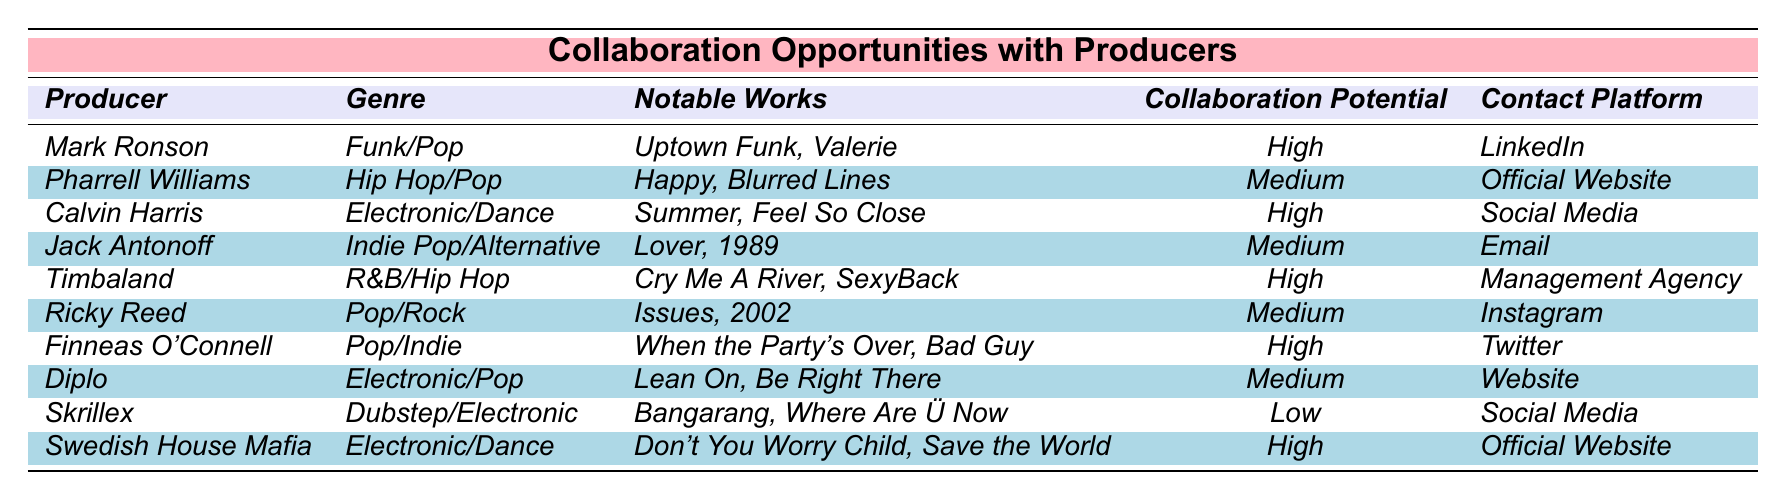What are the contact platforms for Calvin Harris and Timbaland? According to the table, Calvin Harris is reachable via Social Media while Timbaland can be contacted through a Management Agency.
Answer: Social Media and Management Agency Who are the producers listed with a high collaboration potential? The table indicates that Mark Ronson, Calvin Harris, Timbaland, Finneas O'Connell, and Swedish House Mafia all have a collaboration potential rated as high.
Answer: Mark Ronson, Calvin Harris, Timbaland, Finneas O'Connell, Swedish House Mafia Is Timabaland associated with Pop genre? The table shows that Timbaland is categorized under R&B/Hip Hop, not Pop.
Answer: No How many producers are listed as having medium collaboration potential? By counting the entries with medium collaboration potential in the table, we see there are four producers: Pharrell Williams, Jack Antonoff, Ricky Reed, and Diplo.
Answer: 4 Which producer has the most notable works mentioned? By assessing the notable works for each producer, "Uptown Funk, Valerie" by Mark Ronson and "Happy, Blurred Lines" by Pharrell Williams both seem notable, but it is subjective; however, the answer depends on personal familiarity.
Answer: Subjective (depends on the listener) What genre of music does Finnish O'Connell produce? The table categorizes Finneas O'Connell under Pop/Indie genre.
Answer: Pop/Indie Are there any producers from the Electronic/Dance genre with a high collaboration potential? The data indicates that both Calvin Harris and Swedish House Mafia are from the Electronic/Dance genre and have high collaboration potential.
Answer: Yes If I want to reach out to a producer for collaborative work using Instagram, which producer should I choose? The table lists Ricky Reed as the producer whose contact platform is Instagram, making him the one to choose for collaboration.
Answer: Ricky Reed What is the range of collaboration potential across all listed producers? Considering the potential ratings: High (5), Medium (4), and Low (1). Thus, the range of collaboration potential is from Low to High.
Answer: High to Low How many producers have their notable works listed? Each entry in the table includes notable works for each producer, totaling to ten producers, all of whom have notable works listed.
Answer: 10 